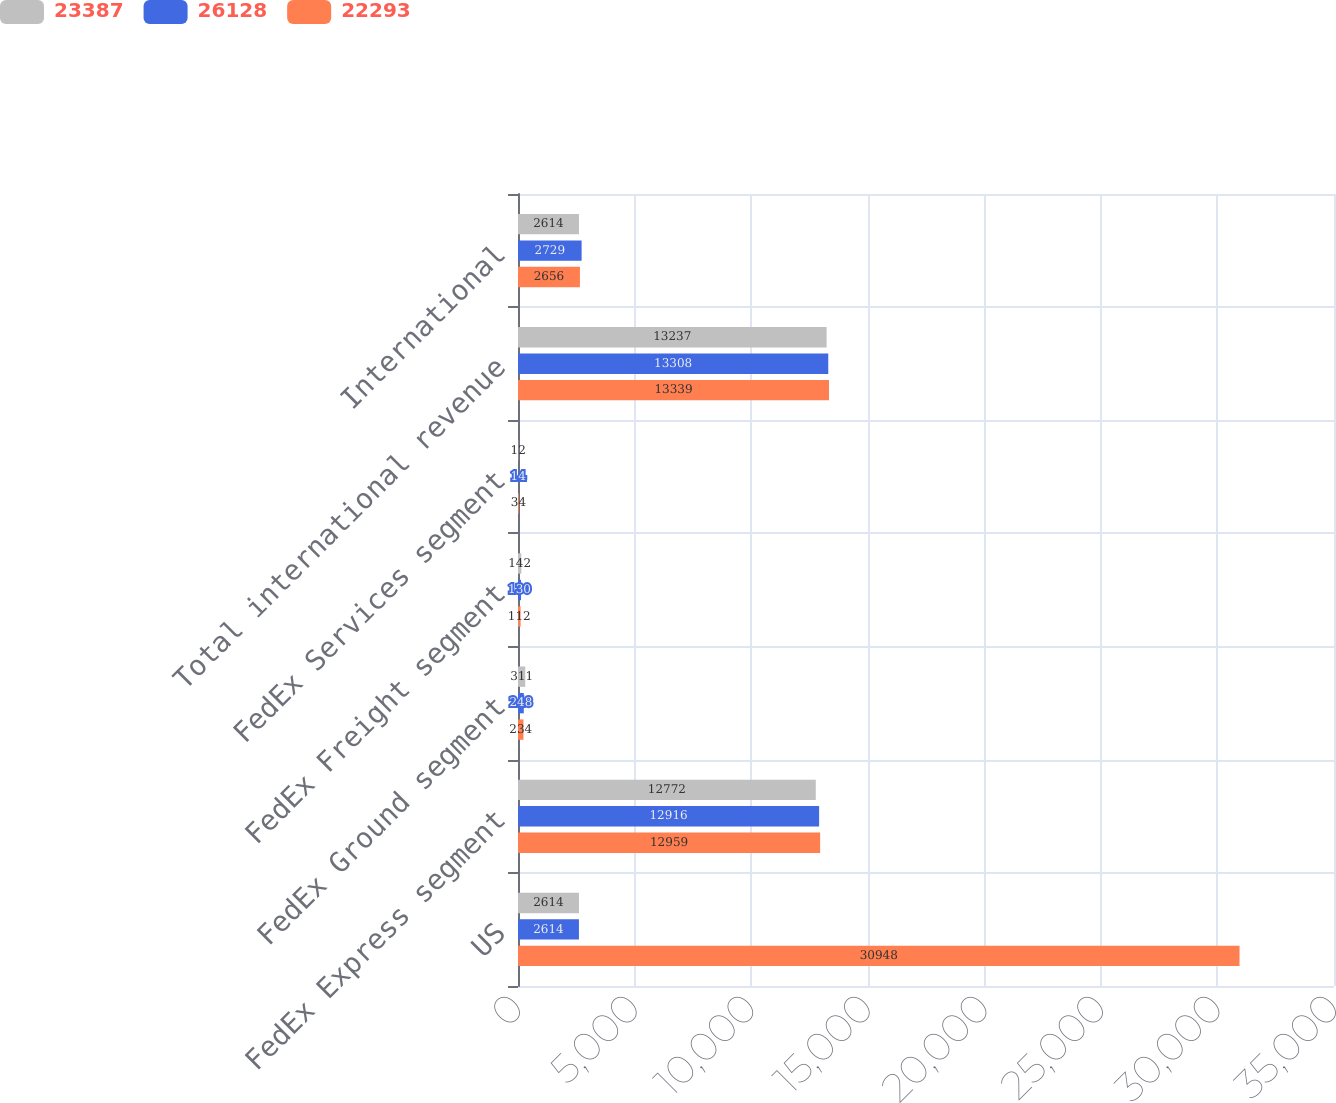Convert chart to OTSL. <chart><loc_0><loc_0><loc_500><loc_500><stacked_bar_chart><ecel><fcel>US<fcel>FedEx Express segment<fcel>FedEx Ground segment<fcel>FedEx Freight segment<fcel>FedEx Services segment<fcel>Total international revenue<fcel>International<nl><fcel>23387<fcel>2614<fcel>12772<fcel>311<fcel>142<fcel>12<fcel>13237<fcel>2614<nl><fcel>26128<fcel>2614<fcel>12916<fcel>248<fcel>130<fcel>14<fcel>13308<fcel>2729<nl><fcel>22293<fcel>30948<fcel>12959<fcel>234<fcel>112<fcel>34<fcel>13339<fcel>2656<nl></chart> 